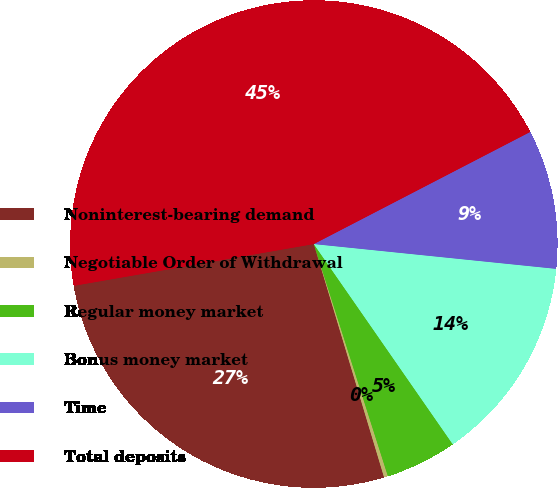<chart> <loc_0><loc_0><loc_500><loc_500><pie_chart><fcel>Noninterest-bearing demand<fcel>Negotiable Order of Withdrawal<fcel>Regular money market<fcel>Bonus money market<fcel>Time<fcel>Total deposits<nl><fcel>26.91%<fcel>0.26%<fcel>4.74%<fcel>13.72%<fcel>9.23%<fcel>45.13%<nl></chart> 